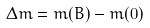Convert formula to latex. <formula><loc_0><loc_0><loc_500><loc_500>\Delta m = m ( B ) - m ( 0 )</formula> 